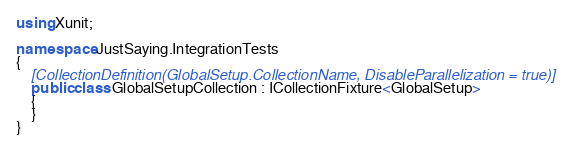<code> <loc_0><loc_0><loc_500><loc_500><_C#_>using Xunit;

namespace JustSaying.IntegrationTests
{
    [CollectionDefinition(GlobalSetup.CollectionName, DisableParallelization = true)]
    public class GlobalSetupCollection : ICollectionFixture<GlobalSetup>
    {
    }
}
</code> 